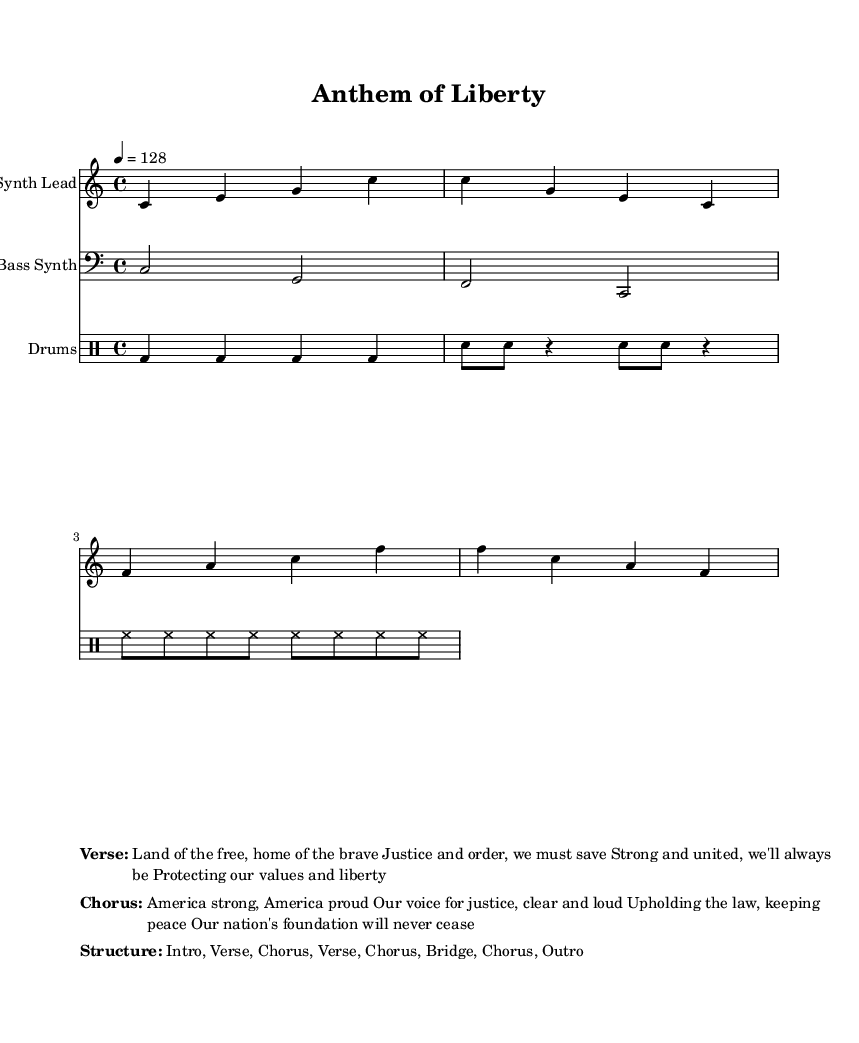What is the key signature of this music? The key signature of the piece is C major, indicated at the beginning of the music, which has no sharps or flats.
Answer: C major What is the time signature? The time signature is specified at the beginning as 4/4, which means there are four beats in each measure and the quarter note gets one beat.
Answer: 4/4 What is the tempo marking? The tempo marking is indicated with "4 = 128", which means there are 128 beats per minute, translating to moderately fast.
Answer: 128 How many sections are in the structure? The structure is outlined as "Intro, Verse, Chorus, Verse, Chorus, Bridge, Chorus, Outro", which contains a total of 8 sections.
Answer: 8 What is the primary theme expressed in the chorus? The chorus emphasizes strength and pride in America, mentioning justice and law, reflecting traditional American values.
Answer: America strong, America proud What instruments are featured in the music? The music features three types of instruments: Synth Lead, Bass Synth, and Drums, each designated in their respective staves.
Answer: Synth Lead, Bass Synth, Drums What type of drum pattern is used? The drum pattern includes bass drum, snare, and hi-hats played in a consistent rhythm, typical of electronic music.
Answer: Electronic drum pattern 